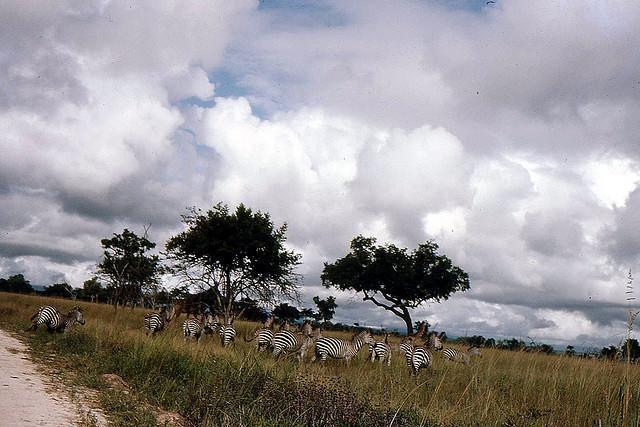How many dogs are in the picture?
Give a very brief answer. 0. 